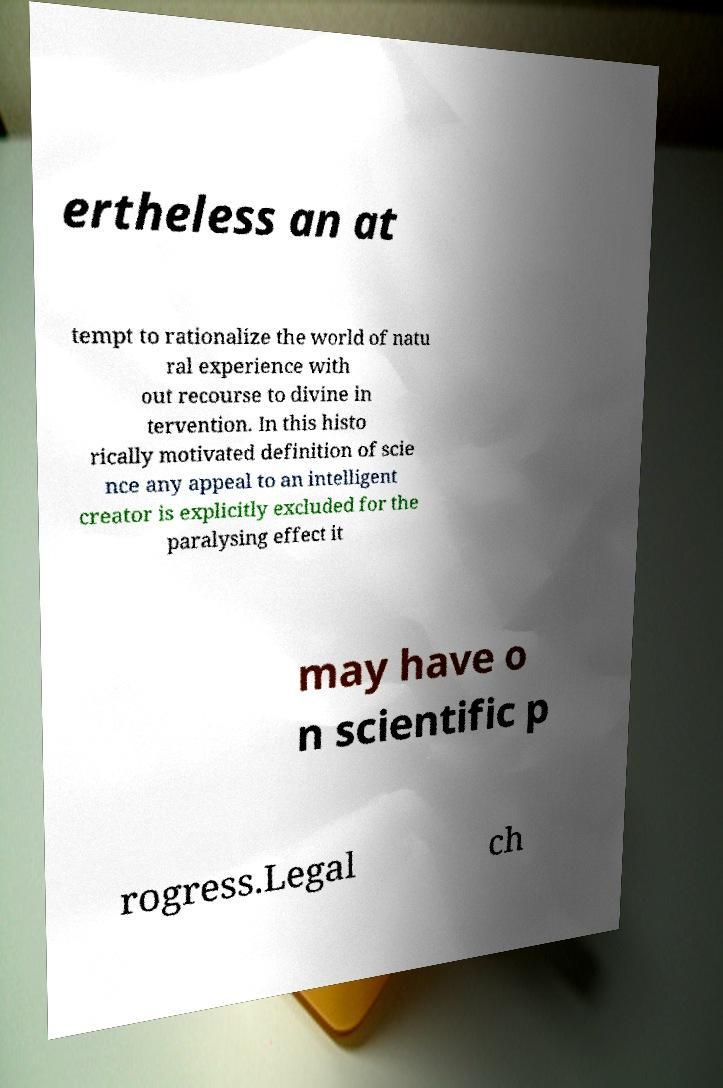I need the written content from this picture converted into text. Can you do that? ertheless an at tempt to rationalize the world of natu ral experience with out recourse to divine in tervention. In this histo rically motivated definition of scie nce any appeal to an intelligent creator is explicitly excluded for the paralysing effect it may have o n scientific p rogress.Legal ch 